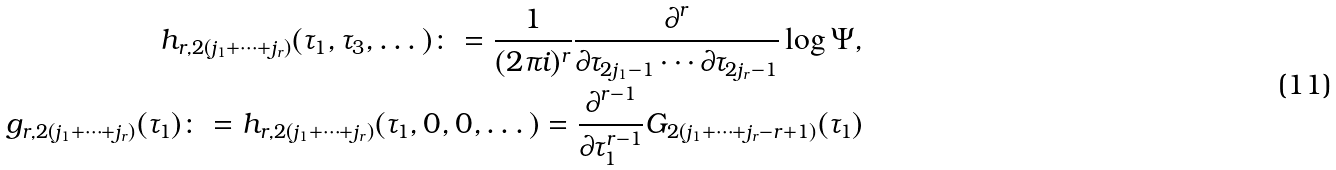Convert formula to latex. <formula><loc_0><loc_0><loc_500><loc_500>h _ { r , 2 ( j _ { 1 } + \dots + j _ { r } ) } ( \tau _ { 1 } , \tau _ { 3 } , \dots ) \colon = \frac { 1 } { ( 2 \pi i ) ^ { r } } \frac { \partial ^ { r } } { \partial \tau _ { 2 j _ { 1 } - 1 } \cdots \partial \tau _ { 2 j _ { r } - 1 } } \log \Psi , \\ g _ { r , 2 ( j _ { 1 } + \dots + j _ { r } ) } ( \tau _ { 1 } ) \colon = h _ { r , 2 ( j _ { 1 } + \dots + j _ { r } ) } ( \tau _ { 1 } , 0 , 0 , \dots ) = \frac { \partial ^ { r - 1 } } { \partial \tau _ { 1 } ^ { r - 1 } } G _ { 2 ( j _ { 1 } + \dots + j _ { r } - r + 1 ) } ( \tau _ { 1 } )</formula> 